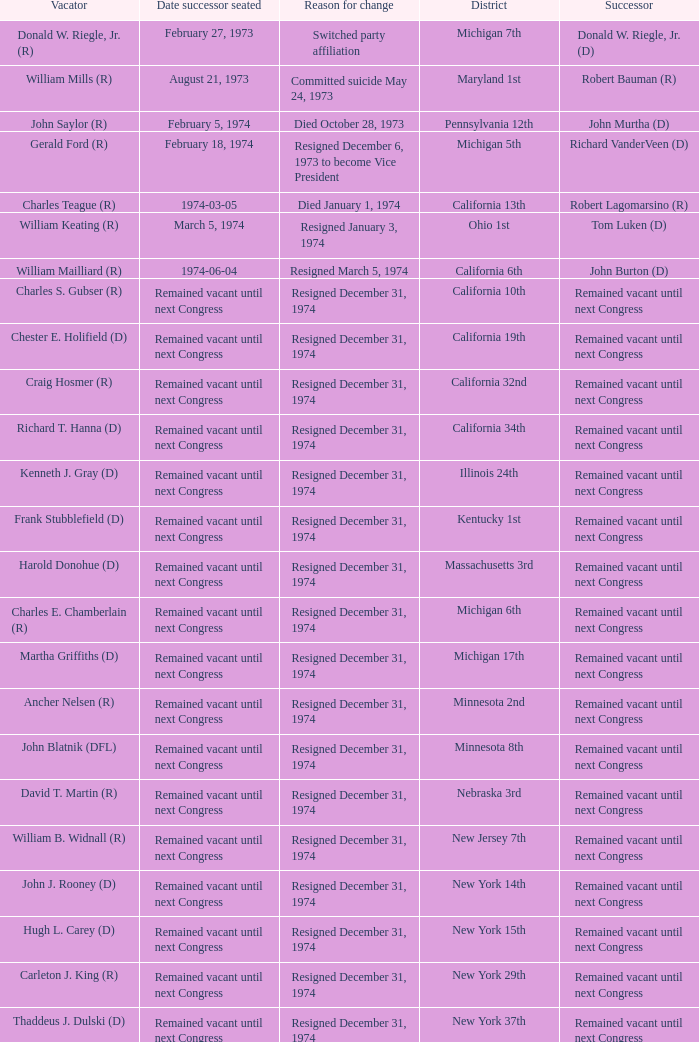When was the successor seated when the district was California 10th? Remained vacant until next Congress. 